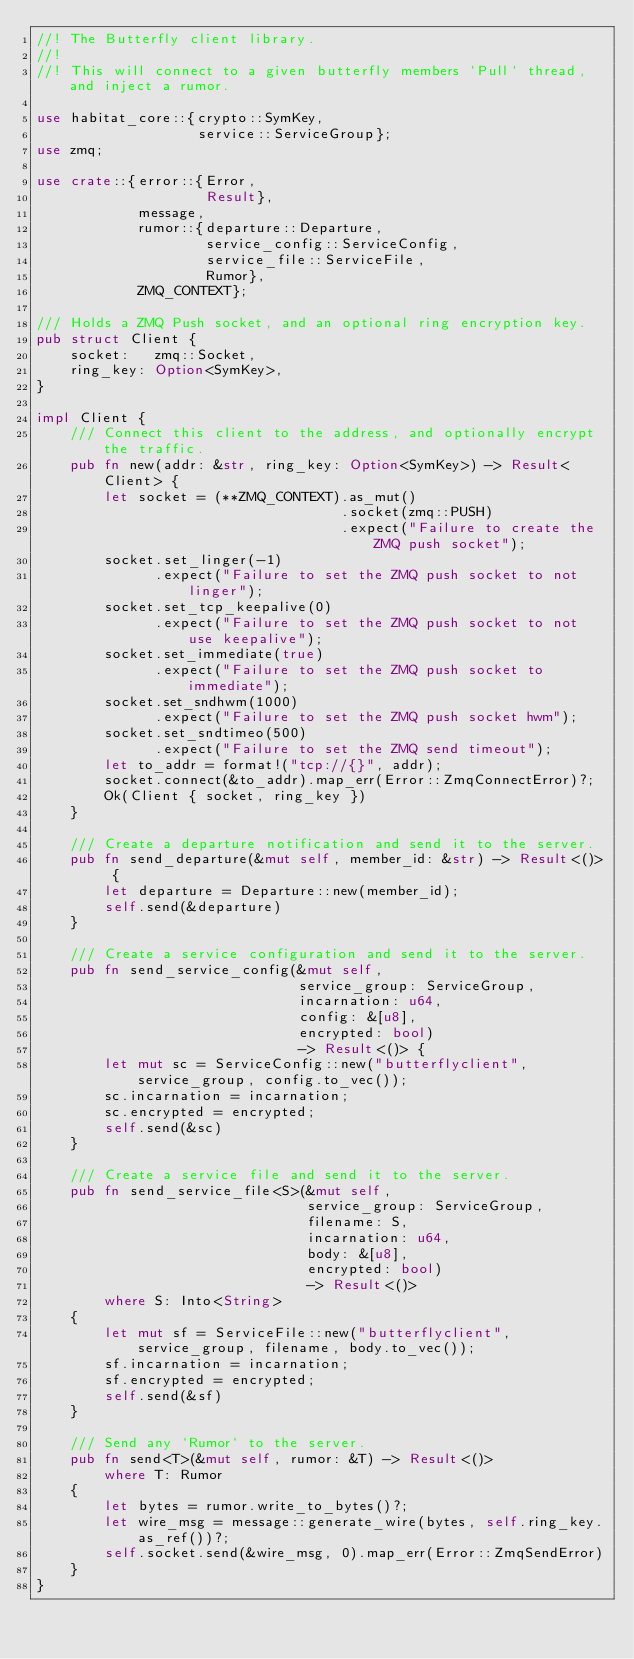<code> <loc_0><loc_0><loc_500><loc_500><_Rust_>//! The Butterfly client library.
//!
//! This will connect to a given butterfly members `Pull` thread, and inject a rumor.

use habitat_core::{crypto::SymKey,
                   service::ServiceGroup};
use zmq;

use crate::{error::{Error,
                    Result},
            message,
            rumor::{departure::Departure,
                    service_config::ServiceConfig,
                    service_file::ServiceFile,
                    Rumor},
            ZMQ_CONTEXT};

/// Holds a ZMQ Push socket, and an optional ring encryption key.
pub struct Client {
    socket:   zmq::Socket,
    ring_key: Option<SymKey>,
}

impl Client {
    /// Connect this client to the address, and optionally encrypt the traffic.
    pub fn new(addr: &str, ring_key: Option<SymKey>) -> Result<Client> {
        let socket = (**ZMQ_CONTEXT).as_mut()
                                    .socket(zmq::PUSH)
                                    .expect("Failure to create the ZMQ push socket");
        socket.set_linger(-1)
              .expect("Failure to set the ZMQ push socket to not linger");
        socket.set_tcp_keepalive(0)
              .expect("Failure to set the ZMQ push socket to not use keepalive");
        socket.set_immediate(true)
              .expect("Failure to set the ZMQ push socket to immediate");
        socket.set_sndhwm(1000)
              .expect("Failure to set the ZMQ push socket hwm");
        socket.set_sndtimeo(500)
              .expect("Failure to set the ZMQ send timeout");
        let to_addr = format!("tcp://{}", addr);
        socket.connect(&to_addr).map_err(Error::ZmqConnectError)?;
        Ok(Client { socket, ring_key })
    }

    /// Create a departure notification and send it to the server.
    pub fn send_departure(&mut self, member_id: &str) -> Result<()> {
        let departure = Departure::new(member_id);
        self.send(&departure)
    }

    /// Create a service configuration and send it to the server.
    pub fn send_service_config(&mut self,
                               service_group: ServiceGroup,
                               incarnation: u64,
                               config: &[u8],
                               encrypted: bool)
                               -> Result<()> {
        let mut sc = ServiceConfig::new("butterflyclient", service_group, config.to_vec());
        sc.incarnation = incarnation;
        sc.encrypted = encrypted;
        self.send(&sc)
    }

    /// Create a service file and send it to the server.
    pub fn send_service_file<S>(&mut self,
                                service_group: ServiceGroup,
                                filename: S,
                                incarnation: u64,
                                body: &[u8],
                                encrypted: bool)
                                -> Result<()>
        where S: Into<String>
    {
        let mut sf = ServiceFile::new("butterflyclient", service_group, filename, body.to_vec());
        sf.incarnation = incarnation;
        sf.encrypted = encrypted;
        self.send(&sf)
    }

    /// Send any `Rumor` to the server.
    pub fn send<T>(&mut self, rumor: &T) -> Result<()>
        where T: Rumor
    {
        let bytes = rumor.write_to_bytes()?;
        let wire_msg = message::generate_wire(bytes, self.ring_key.as_ref())?;
        self.socket.send(&wire_msg, 0).map_err(Error::ZmqSendError)
    }
}
</code> 